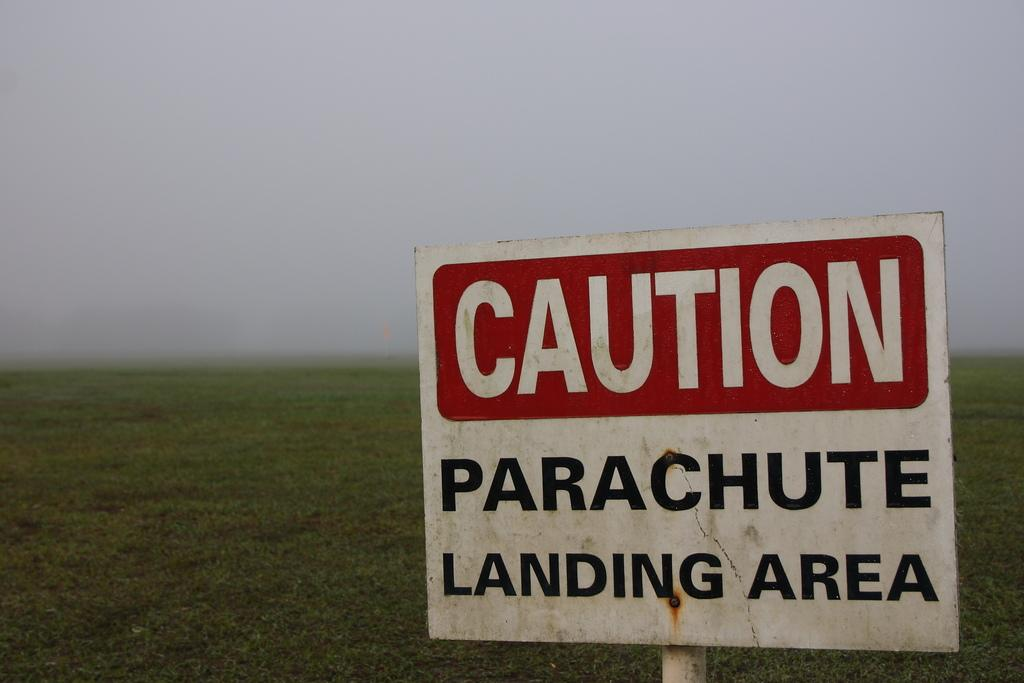<image>
Create a compact narrative representing the image presented. A white sign that says Caution Parachute Landing is before an open field. 